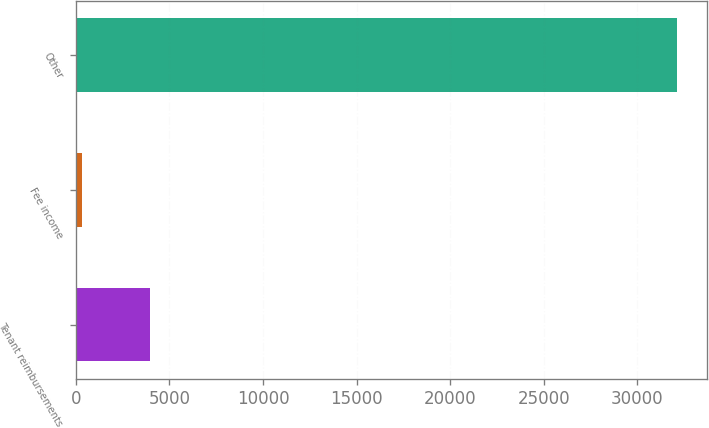Convert chart. <chart><loc_0><loc_0><loc_500><loc_500><bar_chart><fcel>Tenant reimbursements<fcel>Fee income<fcel>Other<nl><fcel>3972<fcel>353<fcel>32119<nl></chart> 